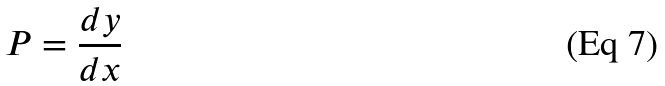Convert formula to latex. <formula><loc_0><loc_0><loc_500><loc_500>P = \frac { d y } { d x }</formula> 